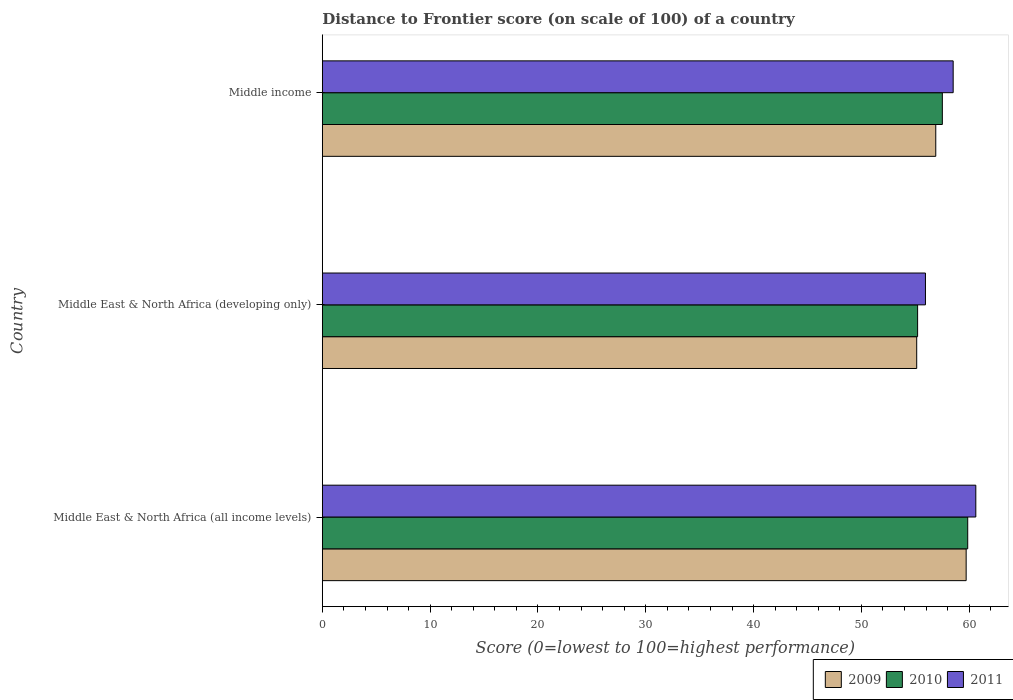Are the number of bars on each tick of the Y-axis equal?
Give a very brief answer. Yes. What is the label of the 3rd group of bars from the top?
Make the answer very short. Middle East & North Africa (all income levels). In how many cases, is the number of bars for a given country not equal to the number of legend labels?
Offer a terse response. 0. What is the distance to frontier score of in 2011 in Middle East & North Africa (developing only)?
Make the answer very short. 55.94. Across all countries, what is the maximum distance to frontier score of in 2011?
Your answer should be compact. 60.61. Across all countries, what is the minimum distance to frontier score of in 2009?
Give a very brief answer. 55.13. In which country was the distance to frontier score of in 2009 maximum?
Your answer should be very brief. Middle East & North Africa (all income levels). In which country was the distance to frontier score of in 2009 minimum?
Provide a short and direct response. Middle East & North Africa (developing only). What is the total distance to frontier score of in 2010 in the graph?
Make the answer very short. 172.59. What is the difference between the distance to frontier score of in 2011 in Middle East & North Africa (all income levels) and that in Middle income?
Provide a succinct answer. 2.1. What is the difference between the distance to frontier score of in 2009 in Middle income and the distance to frontier score of in 2010 in Middle East & North Africa (developing only)?
Give a very brief answer. 1.68. What is the average distance to frontier score of in 2009 per country?
Your answer should be compact. 57.25. What is the difference between the distance to frontier score of in 2011 and distance to frontier score of in 2009 in Middle income?
Keep it short and to the point. 1.61. What is the ratio of the distance to frontier score of in 2010 in Middle East & North Africa (all income levels) to that in Middle income?
Your response must be concise. 1.04. Is the distance to frontier score of in 2011 in Middle East & North Africa (all income levels) less than that in Middle income?
Your answer should be very brief. No. Is the difference between the distance to frontier score of in 2011 in Middle East & North Africa (all income levels) and Middle East & North Africa (developing only) greater than the difference between the distance to frontier score of in 2009 in Middle East & North Africa (all income levels) and Middle East & North Africa (developing only)?
Provide a short and direct response. Yes. What is the difference between the highest and the second highest distance to frontier score of in 2009?
Offer a very short reply. 2.82. What is the difference between the highest and the lowest distance to frontier score of in 2010?
Provide a short and direct response. 4.65. Is the sum of the distance to frontier score of in 2009 in Middle East & North Africa (all income levels) and Middle East & North Africa (developing only) greater than the maximum distance to frontier score of in 2010 across all countries?
Provide a succinct answer. Yes. What does the 1st bar from the top in Middle East & North Africa (developing only) represents?
Keep it short and to the point. 2011. Is it the case that in every country, the sum of the distance to frontier score of in 2010 and distance to frontier score of in 2011 is greater than the distance to frontier score of in 2009?
Offer a terse response. Yes. How many bars are there?
Your response must be concise. 9. Are all the bars in the graph horizontal?
Provide a short and direct response. Yes. Does the graph contain any zero values?
Provide a succinct answer. No. How are the legend labels stacked?
Offer a terse response. Horizontal. What is the title of the graph?
Your answer should be compact. Distance to Frontier score (on scale of 100) of a country. Does "1969" appear as one of the legend labels in the graph?
Your response must be concise. No. What is the label or title of the X-axis?
Offer a terse response. Score (0=lowest to 100=highest performance). What is the Score (0=lowest to 100=highest performance) in 2009 in Middle East & North Africa (all income levels)?
Give a very brief answer. 59.72. What is the Score (0=lowest to 100=highest performance) in 2010 in Middle East & North Africa (all income levels)?
Ensure brevity in your answer.  59.86. What is the Score (0=lowest to 100=highest performance) in 2011 in Middle East & North Africa (all income levels)?
Your answer should be compact. 60.61. What is the Score (0=lowest to 100=highest performance) of 2009 in Middle East & North Africa (developing only)?
Your answer should be very brief. 55.13. What is the Score (0=lowest to 100=highest performance) in 2010 in Middle East & North Africa (developing only)?
Ensure brevity in your answer.  55.22. What is the Score (0=lowest to 100=highest performance) in 2011 in Middle East & North Africa (developing only)?
Provide a short and direct response. 55.94. What is the Score (0=lowest to 100=highest performance) of 2009 in Middle income?
Give a very brief answer. 56.9. What is the Score (0=lowest to 100=highest performance) in 2010 in Middle income?
Offer a very short reply. 57.51. What is the Score (0=lowest to 100=highest performance) of 2011 in Middle income?
Your answer should be compact. 58.51. Across all countries, what is the maximum Score (0=lowest to 100=highest performance) in 2009?
Provide a short and direct response. 59.72. Across all countries, what is the maximum Score (0=lowest to 100=highest performance) in 2010?
Your response must be concise. 59.86. Across all countries, what is the maximum Score (0=lowest to 100=highest performance) in 2011?
Keep it short and to the point. 60.61. Across all countries, what is the minimum Score (0=lowest to 100=highest performance) of 2009?
Provide a succinct answer. 55.13. Across all countries, what is the minimum Score (0=lowest to 100=highest performance) in 2010?
Make the answer very short. 55.22. Across all countries, what is the minimum Score (0=lowest to 100=highest performance) of 2011?
Your answer should be compact. 55.94. What is the total Score (0=lowest to 100=highest performance) of 2009 in the graph?
Offer a very short reply. 171.75. What is the total Score (0=lowest to 100=highest performance) in 2010 in the graph?
Your response must be concise. 172.59. What is the total Score (0=lowest to 100=highest performance) of 2011 in the graph?
Provide a succinct answer. 175.07. What is the difference between the Score (0=lowest to 100=highest performance) in 2009 in Middle East & North Africa (all income levels) and that in Middle East & North Africa (developing only)?
Your response must be concise. 4.59. What is the difference between the Score (0=lowest to 100=highest performance) in 2010 in Middle East & North Africa (all income levels) and that in Middle East & North Africa (developing only)?
Your answer should be compact. 4.65. What is the difference between the Score (0=lowest to 100=highest performance) in 2011 in Middle East & North Africa (all income levels) and that in Middle East & North Africa (developing only)?
Your response must be concise. 4.67. What is the difference between the Score (0=lowest to 100=highest performance) of 2009 in Middle East & North Africa (all income levels) and that in Middle income?
Keep it short and to the point. 2.82. What is the difference between the Score (0=lowest to 100=highest performance) of 2010 in Middle East & North Africa (all income levels) and that in Middle income?
Ensure brevity in your answer.  2.35. What is the difference between the Score (0=lowest to 100=highest performance) in 2011 in Middle East & North Africa (all income levels) and that in Middle income?
Keep it short and to the point. 2.1. What is the difference between the Score (0=lowest to 100=highest performance) in 2009 in Middle East & North Africa (developing only) and that in Middle income?
Make the answer very short. -1.77. What is the difference between the Score (0=lowest to 100=highest performance) in 2010 in Middle East & North Africa (developing only) and that in Middle income?
Provide a succinct answer. -2.29. What is the difference between the Score (0=lowest to 100=highest performance) in 2011 in Middle East & North Africa (developing only) and that in Middle income?
Offer a terse response. -2.57. What is the difference between the Score (0=lowest to 100=highest performance) in 2009 in Middle East & North Africa (all income levels) and the Score (0=lowest to 100=highest performance) in 2010 in Middle East & North Africa (developing only)?
Your answer should be very brief. 4.5. What is the difference between the Score (0=lowest to 100=highest performance) of 2009 in Middle East & North Africa (all income levels) and the Score (0=lowest to 100=highest performance) of 2011 in Middle East & North Africa (developing only)?
Offer a very short reply. 3.78. What is the difference between the Score (0=lowest to 100=highest performance) of 2010 in Middle East & North Africa (all income levels) and the Score (0=lowest to 100=highest performance) of 2011 in Middle East & North Africa (developing only)?
Offer a very short reply. 3.92. What is the difference between the Score (0=lowest to 100=highest performance) in 2009 in Middle East & North Africa (all income levels) and the Score (0=lowest to 100=highest performance) in 2010 in Middle income?
Provide a short and direct response. 2.21. What is the difference between the Score (0=lowest to 100=highest performance) in 2009 in Middle East & North Africa (all income levels) and the Score (0=lowest to 100=highest performance) in 2011 in Middle income?
Provide a short and direct response. 1.21. What is the difference between the Score (0=lowest to 100=highest performance) in 2010 in Middle East & North Africa (all income levels) and the Score (0=lowest to 100=highest performance) in 2011 in Middle income?
Make the answer very short. 1.35. What is the difference between the Score (0=lowest to 100=highest performance) in 2009 in Middle East & North Africa (developing only) and the Score (0=lowest to 100=highest performance) in 2010 in Middle income?
Provide a succinct answer. -2.38. What is the difference between the Score (0=lowest to 100=highest performance) in 2009 in Middle East & North Africa (developing only) and the Score (0=lowest to 100=highest performance) in 2011 in Middle income?
Keep it short and to the point. -3.38. What is the difference between the Score (0=lowest to 100=highest performance) in 2010 in Middle East & North Africa (developing only) and the Score (0=lowest to 100=highest performance) in 2011 in Middle income?
Make the answer very short. -3.3. What is the average Score (0=lowest to 100=highest performance) in 2009 per country?
Your answer should be very brief. 57.25. What is the average Score (0=lowest to 100=highest performance) in 2010 per country?
Provide a short and direct response. 57.53. What is the average Score (0=lowest to 100=highest performance) in 2011 per country?
Make the answer very short. 58.36. What is the difference between the Score (0=lowest to 100=highest performance) in 2009 and Score (0=lowest to 100=highest performance) in 2010 in Middle East & North Africa (all income levels)?
Make the answer very short. -0.14. What is the difference between the Score (0=lowest to 100=highest performance) of 2009 and Score (0=lowest to 100=highest performance) of 2011 in Middle East & North Africa (all income levels)?
Keep it short and to the point. -0.9. What is the difference between the Score (0=lowest to 100=highest performance) in 2010 and Score (0=lowest to 100=highest performance) in 2011 in Middle East & North Africa (all income levels)?
Provide a succinct answer. -0.75. What is the difference between the Score (0=lowest to 100=highest performance) in 2009 and Score (0=lowest to 100=highest performance) in 2010 in Middle East & North Africa (developing only)?
Offer a terse response. -0.08. What is the difference between the Score (0=lowest to 100=highest performance) in 2009 and Score (0=lowest to 100=highest performance) in 2011 in Middle East & North Africa (developing only)?
Give a very brief answer. -0.81. What is the difference between the Score (0=lowest to 100=highest performance) of 2010 and Score (0=lowest to 100=highest performance) of 2011 in Middle East & North Africa (developing only)?
Keep it short and to the point. -0.73. What is the difference between the Score (0=lowest to 100=highest performance) in 2009 and Score (0=lowest to 100=highest performance) in 2010 in Middle income?
Make the answer very short. -0.61. What is the difference between the Score (0=lowest to 100=highest performance) in 2009 and Score (0=lowest to 100=highest performance) in 2011 in Middle income?
Provide a short and direct response. -1.61. What is the difference between the Score (0=lowest to 100=highest performance) in 2010 and Score (0=lowest to 100=highest performance) in 2011 in Middle income?
Provide a succinct answer. -1. What is the ratio of the Score (0=lowest to 100=highest performance) of 2009 in Middle East & North Africa (all income levels) to that in Middle East & North Africa (developing only)?
Offer a terse response. 1.08. What is the ratio of the Score (0=lowest to 100=highest performance) in 2010 in Middle East & North Africa (all income levels) to that in Middle East & North Africa (developing only)?
Your answer should be very brief. 1.08. What is the ratio of the Score (0=lowest to 100=highest performance) of 2011 in Middle East & North Africa (all income levels) to that in Middle East & North Africa (developing only)?
Provide a short and direct response. 1.08. What is the ratio of the Score (0=lowest to 100=highest performance) of 2009 in Middle East & North Africa (all income levels) to that in Middle income?
Your response must be concise. 1.05. What is the ratio of the Score (0=lowest to 100=highest performance) of 2010 in Middle East & North Africa (all income levels) to that in Middle income?
Make the answer very short. 1.04. What is the ratio of the Score (0=lowest to 100=highest performance) of 2011 in Middle East & North Africa (all income levels) to that in Middle income?
Your answer should be very brief. 1.04. What is the ratio of the Score (0=lowest to 100=highest performance) in 2009 in Middle East & North Africa (developing only) to that in Middle income?
Offer a terse response. 0.97. What is the ratio of the Score (0=lowest to 100=highest performance) of 2010 in Middle East & North Africa (developing only) to that in Middle income?
Your answer should be compact. 0.96. What is the ratio of the Score (0=lowest to 100=highest performance) of 2011 in Middle East & North Africa (developing only) to that in Middle income?
Make the answer very short. 0.96. What is the difference between the highest and the second highest Score (0=lowest to 100=highest performance) of 2009?
Provide a succinct answer. 2.82. What is the difference between the highest and the second highest Score (0=lowest to 100=highest performance) of 2010?
Ensure brevity in your answer.  2.35. What is the difference between the highest and the second highest Score (0=lowest to 100=highest performance) in 2011?
Make the answer very short. 2.1. What is the difference between the highest and the lowest Score (0=lowest to 100=highest performance) of 2009?
Keep it short and to the point. 4.59. What is the difference between the highest and the lowest Score (0=lowest to 100=highest performance) in 2010?
Your answer should be compact. 4.65. What is the difference between the highest and the lowest Score (0=lowest to 100=highest performance) of 2011?
Your response must be concise. 4.67. 